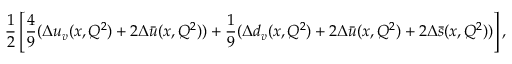Convert formula to latex. <formula><loc_0><loc_0><loc_500><loc_500>{ \frac { 1 } { 2 } } \left [ { \frac { 4 } { 9 } } ( \Delta u _ { v } ( x , Q ^ { 2 } ) + 2 \Delta \bar { u } ( x , Q ^ { 2 } ) ) + { \frac { 1 } { 9 } } ( \Delta d _ { v } ( x , Q ^ { 2 } ) + 2 \Delta \bar { u } ( x , Q ^ { 2 } ) + 2 \Delta \bar { s } ( x , Q ^ { 2 } ) ) \right ] ,</formula> 